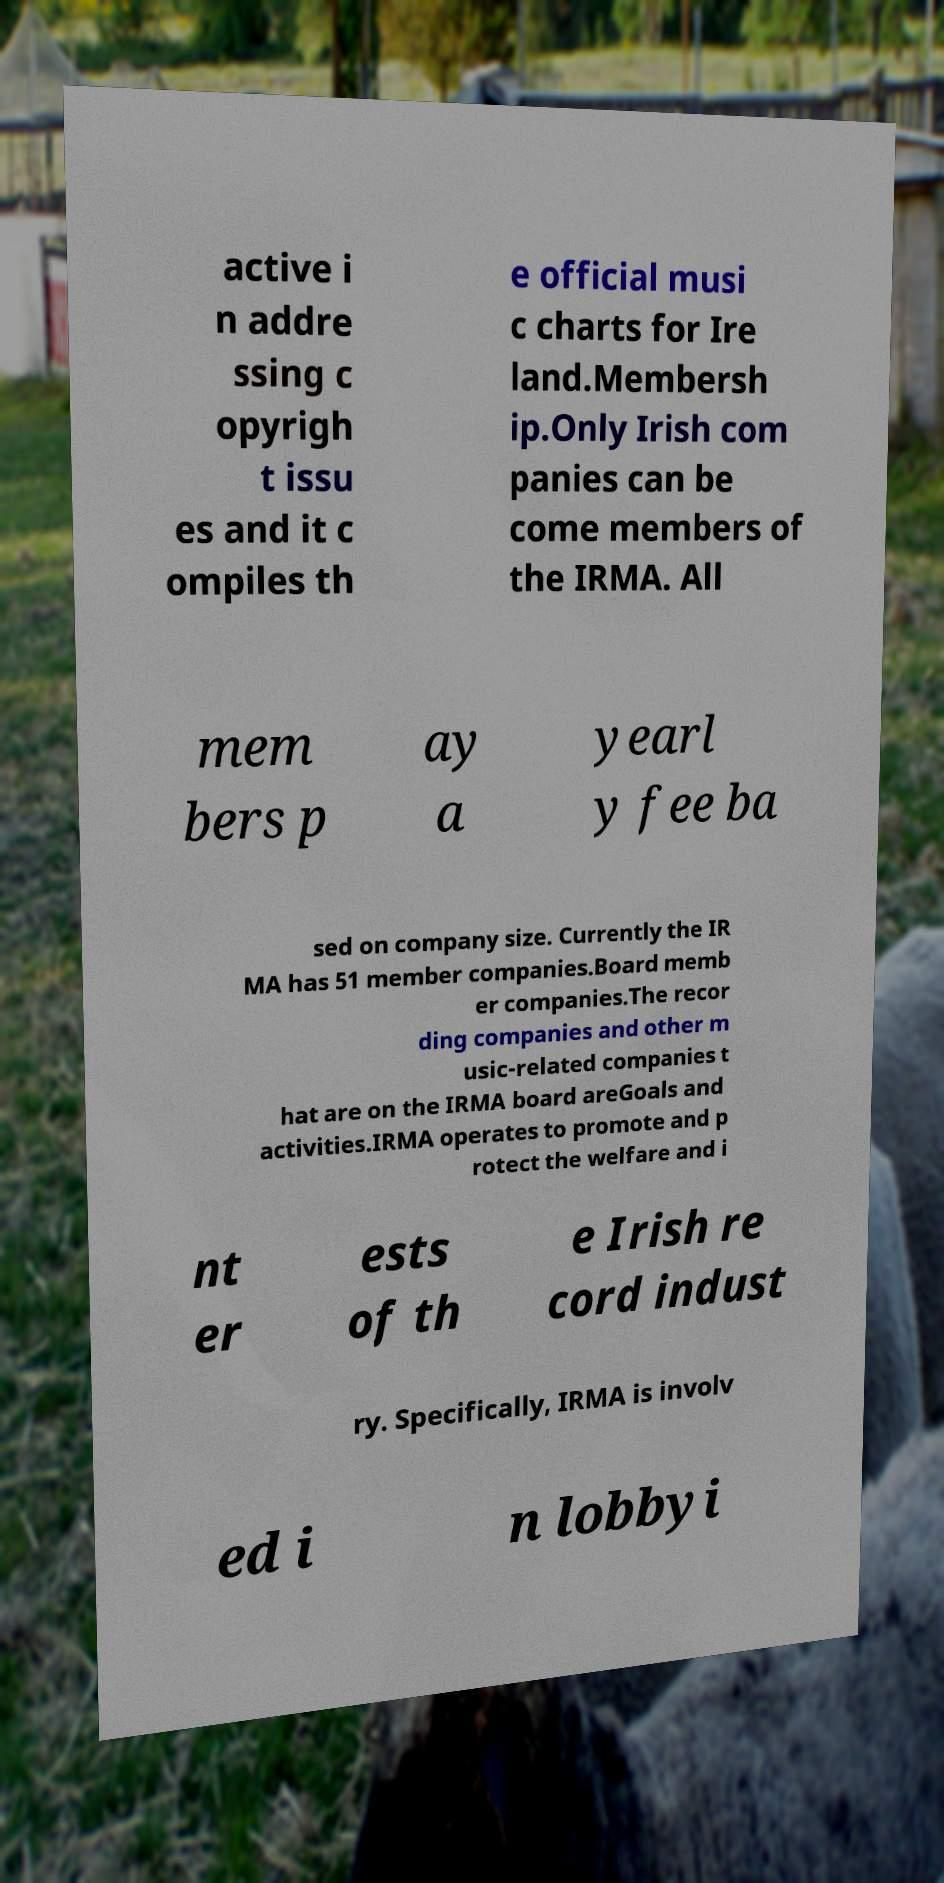Could you assist in decoding the text presented in this image and type it out clearly? active i n addre ssing c opyrigh t issu es and it c ompiles th e official musi c charts for Ire land.Membersh ip.Only Irish com panies can be come members of the IRMA. All mem bers p ay a yearl y fee ba sed on company size. Currently the IR MA has 51 member companies.Board memb er companies.The recor ding companies and other m usic-related companies t hat are on the IRMA board areGoals and activities.IRMA operates to promote and p rotect the welfare and i nt er ests of th e Irish re cord indust ry. Specifically, IRMA is involv ed i n lobbyi 